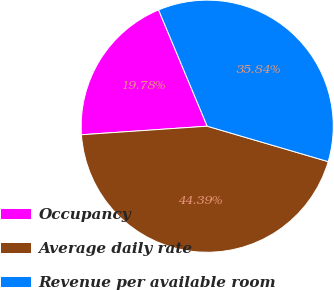Convert chart. <chart><loc_0><loc_0><loc_500><loc_500><pie_chart><fcel>Occupancy<fcel>Average daily rate<fcel>Revenue per available room<nl><fcel>19.78%<fcel>44.39%<fcel>35.84%<nl></chart> 